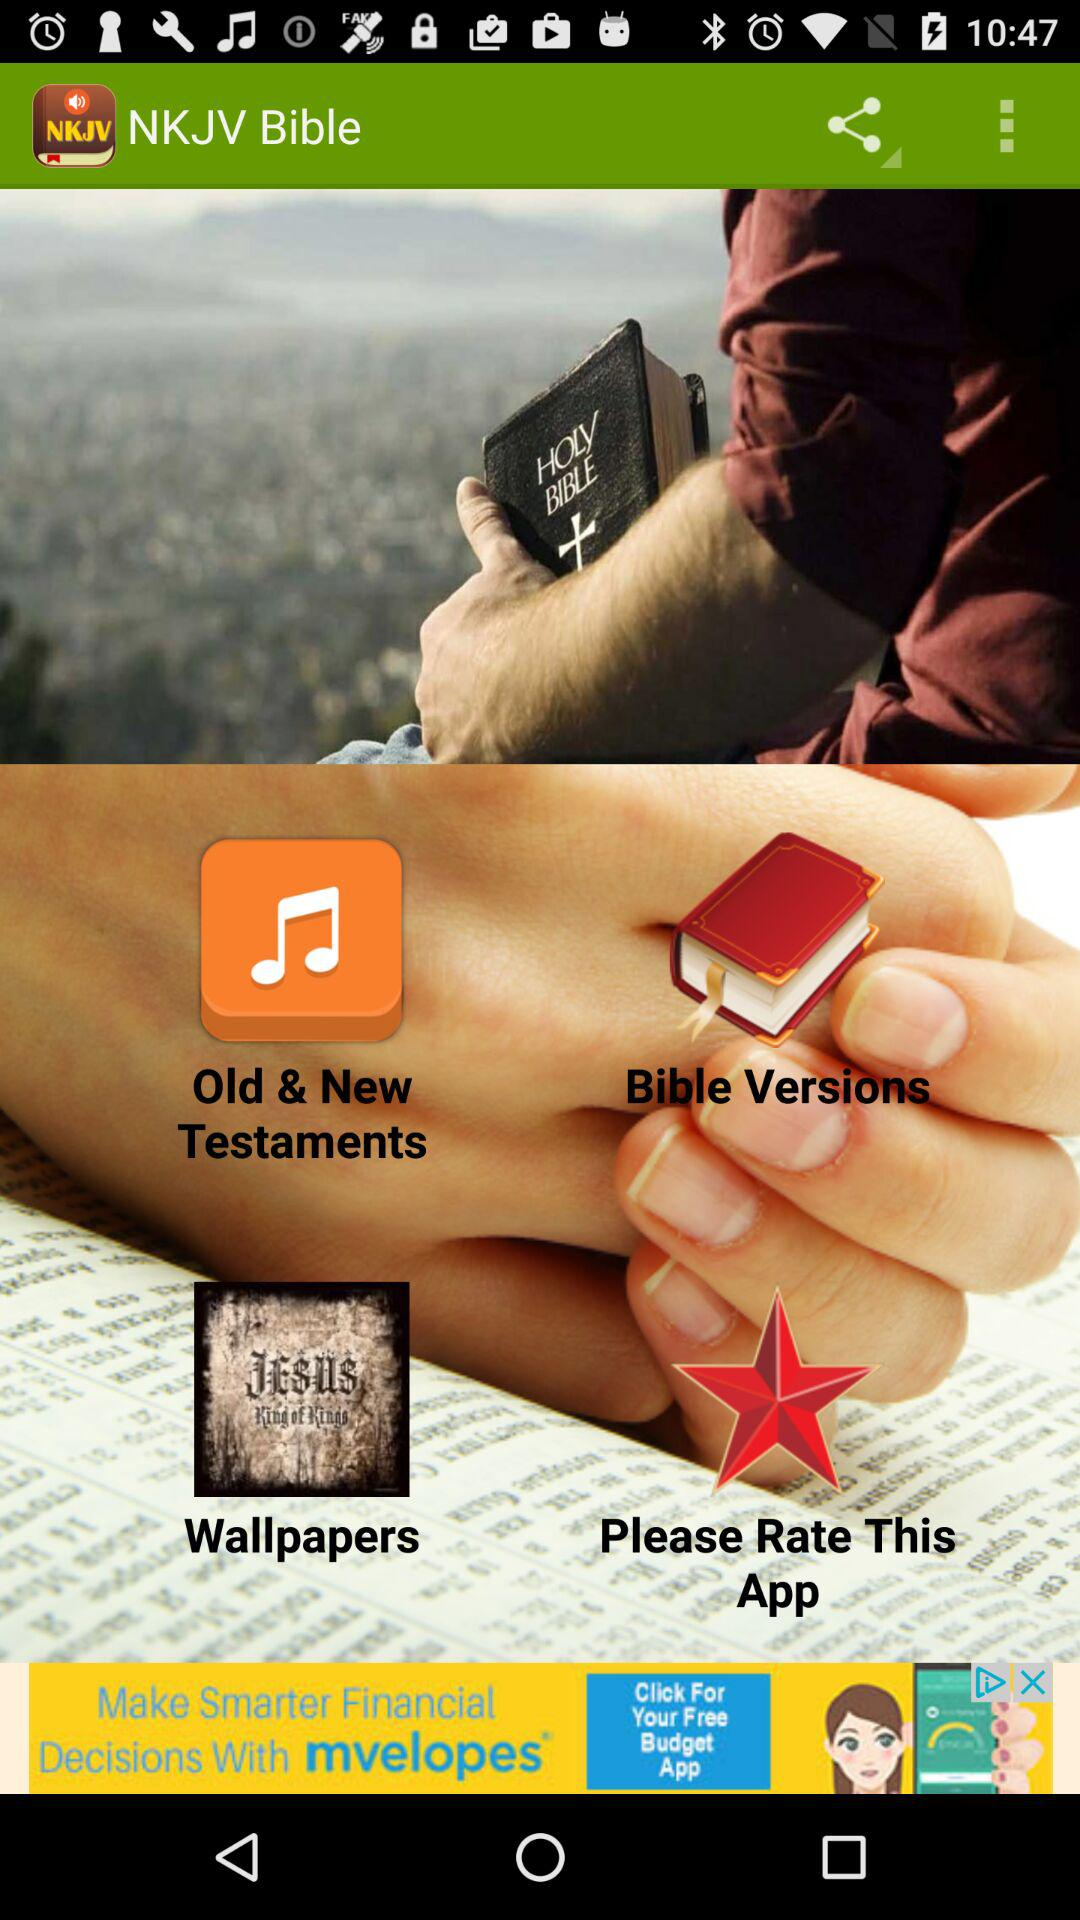How many stars is this application rated?
When the provided information is insufficient, respond with <no answer>. <no answer> 